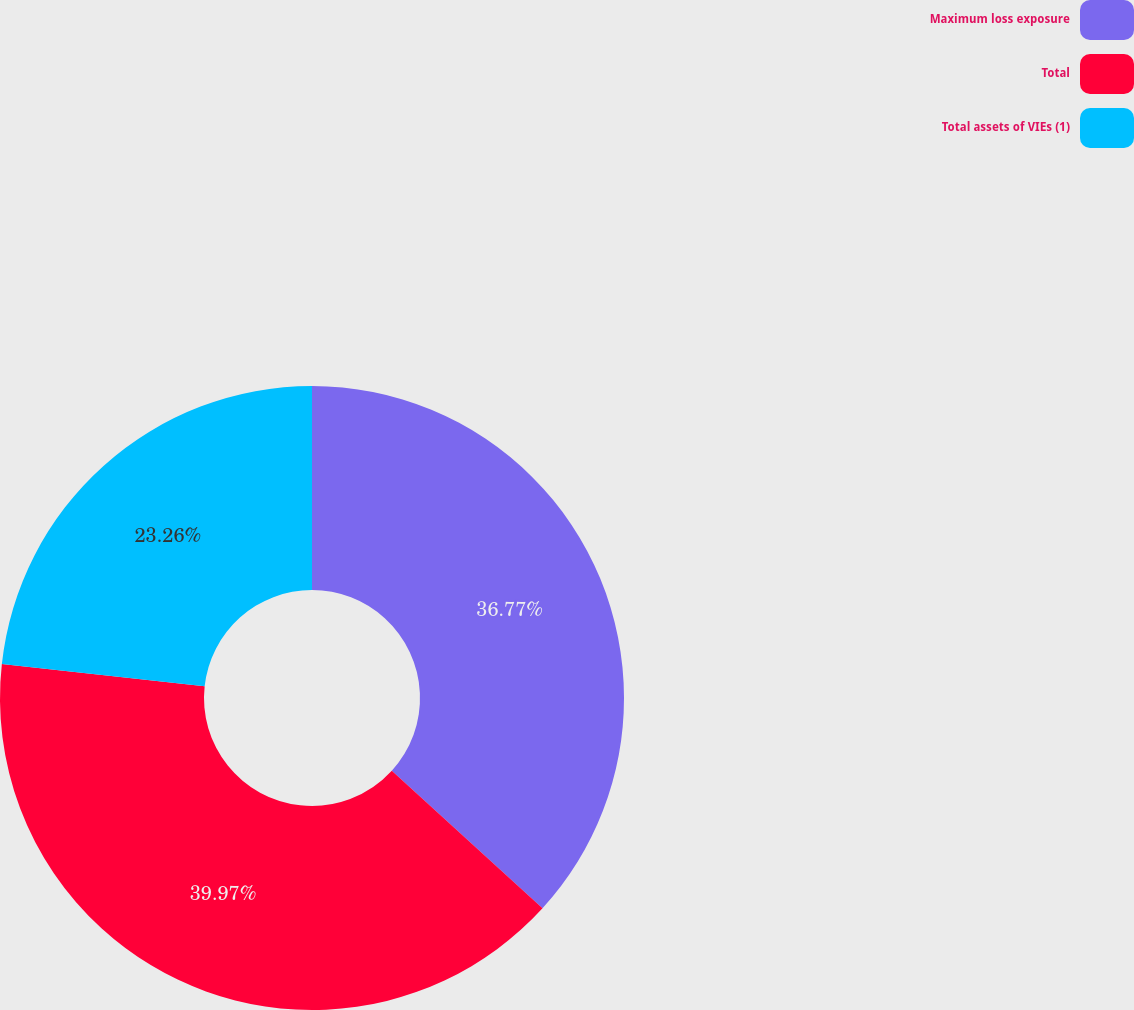<chart> <loc_0><loc_0><loc_500><loc_500><pie_chart><fcel>Maximum loss exposure<fcel>Total<fcel>Total assets of VIEs (1)<nl><fcel>36.77%<fcel>39.97%<fcel>23.26%<nl></chart> 